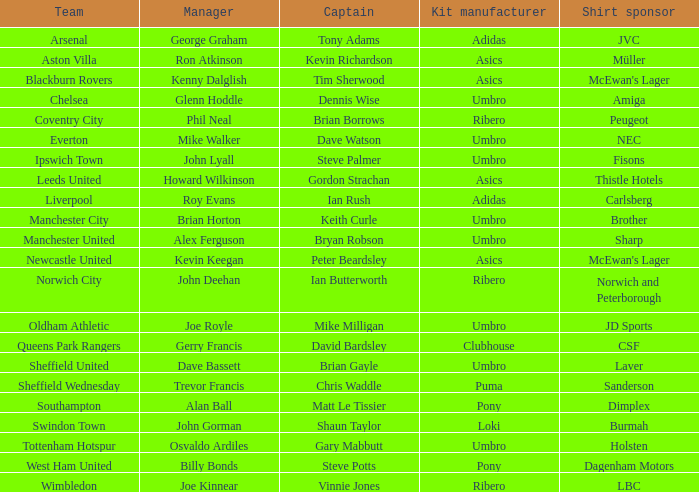Which captain has howard wilkinson as the manager? Gordon Strachan. 